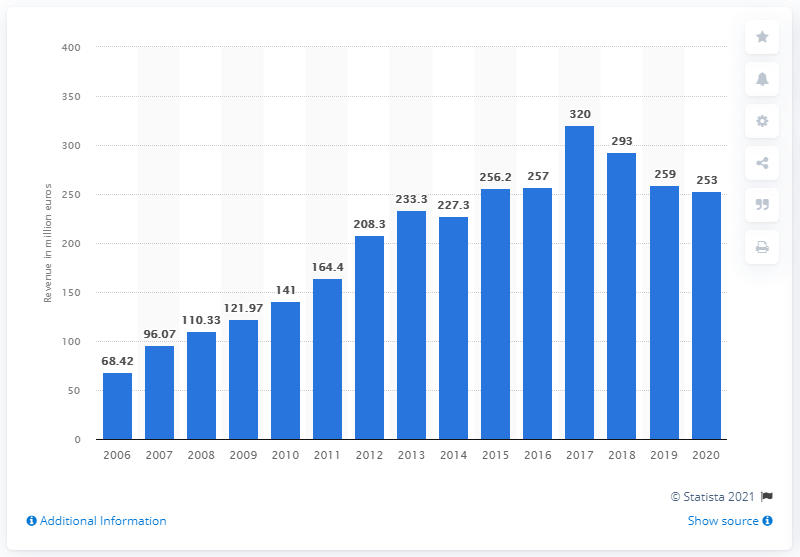Give some essential details in this illustration. In 2020, Gameloft's revenue was approximately 253 million. 